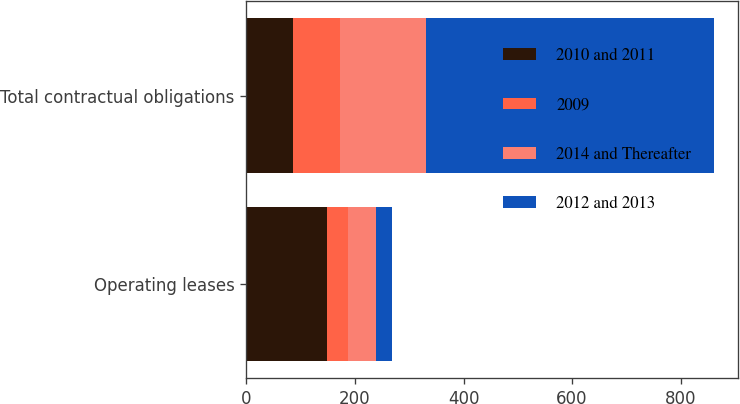<chart> <loc_0><loc_0><loc_500><loc_500><stacked_bar_chart><ecel><fcel>Operating leases<fcel>Total contractual obligations<nl><fcel>2010 and 2011<fcel>149.3<fcel>85.9<nl><fcel>2009<fcel>38.2<fcel>85.9<nl><fcel>2014 and Thereafter<fcel>51<fcel>158.9<nl><fcel>2012 and 2013<fcel>30.2<fcel>531.8<nl></chart> 